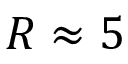<formula> <loc_0><loc_0><loc_500><loc_500>R \approx 5</formula> 